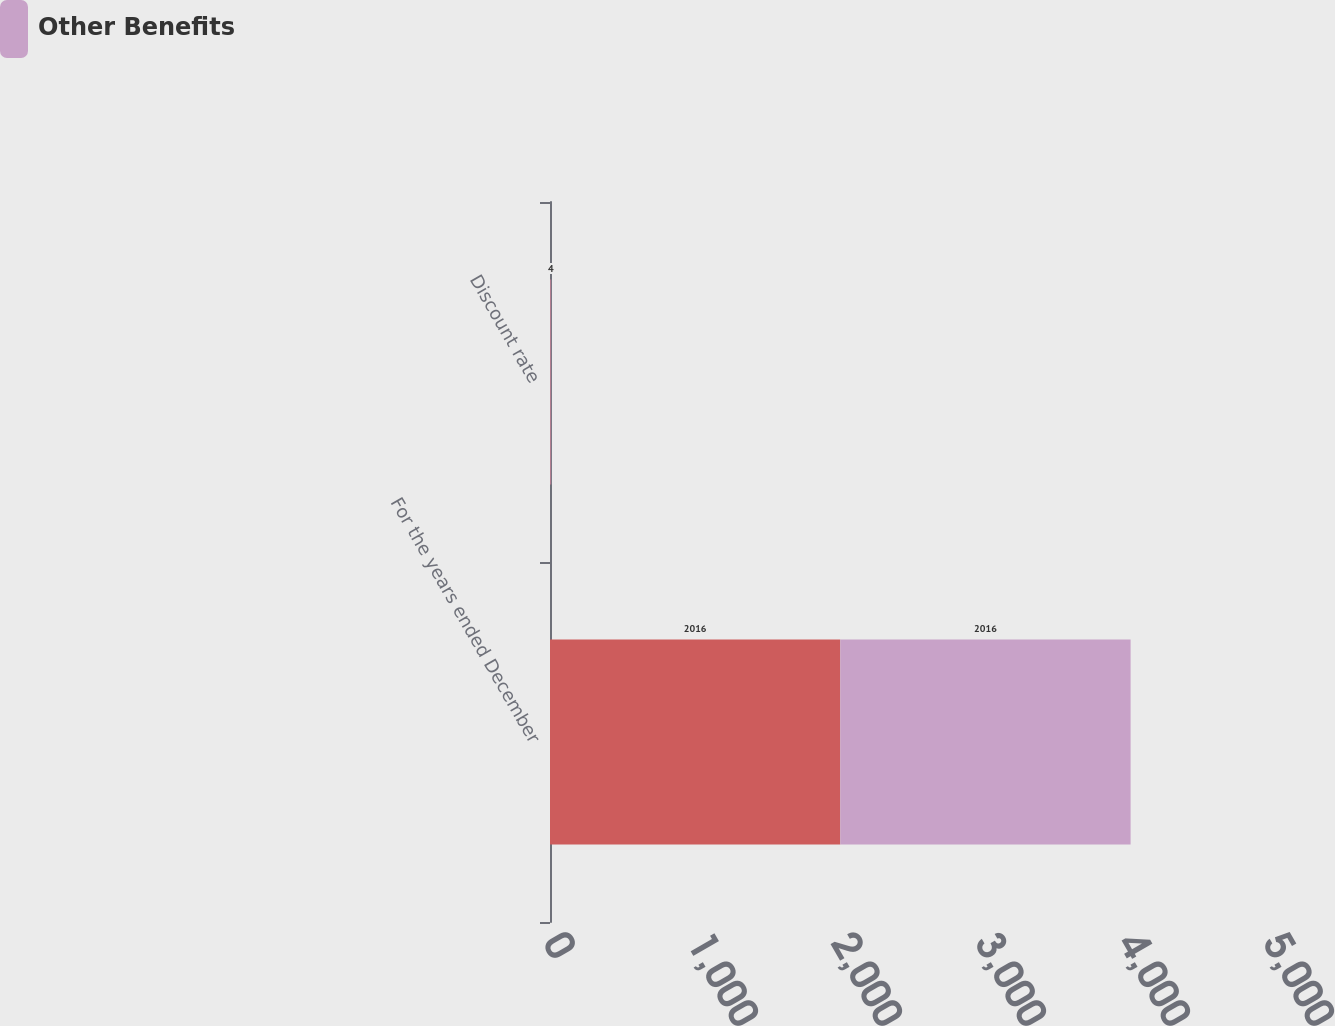Convert chart to OTSL. <chart><loc_0><loc_0><loc_500><loc_500><stacked_bar_chart><ecel><fcel>For the years ended December<fcel>Discount rate<nl><fcel>nan<fcel>2016<fcel>4<nl><fcel>Other Benefits<fcel>2016<fcel>4<nl></chart> 